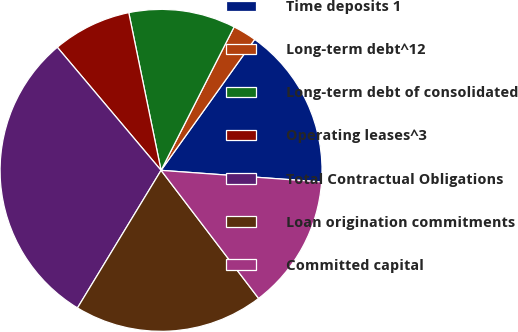Convert chart to OTSL. <chart><loc_0><loc_0><loc_500><loc_500><pie_chart><fcel>Time deposits 1<fcel>Long-term debt^12<fcel>Long-term debt of consolidated<fcel>Operating leases^3<fcel>Total Contractual Obligations<fcel>Loan origination commitments<fcel>Committed capital<nl><fcel>16.27%<fcel>2.38%<fcel>10.71%<fcel>7.93%<fcel>30.16%<fcel>19.05%<fcel>13.49%<nl></chart> 